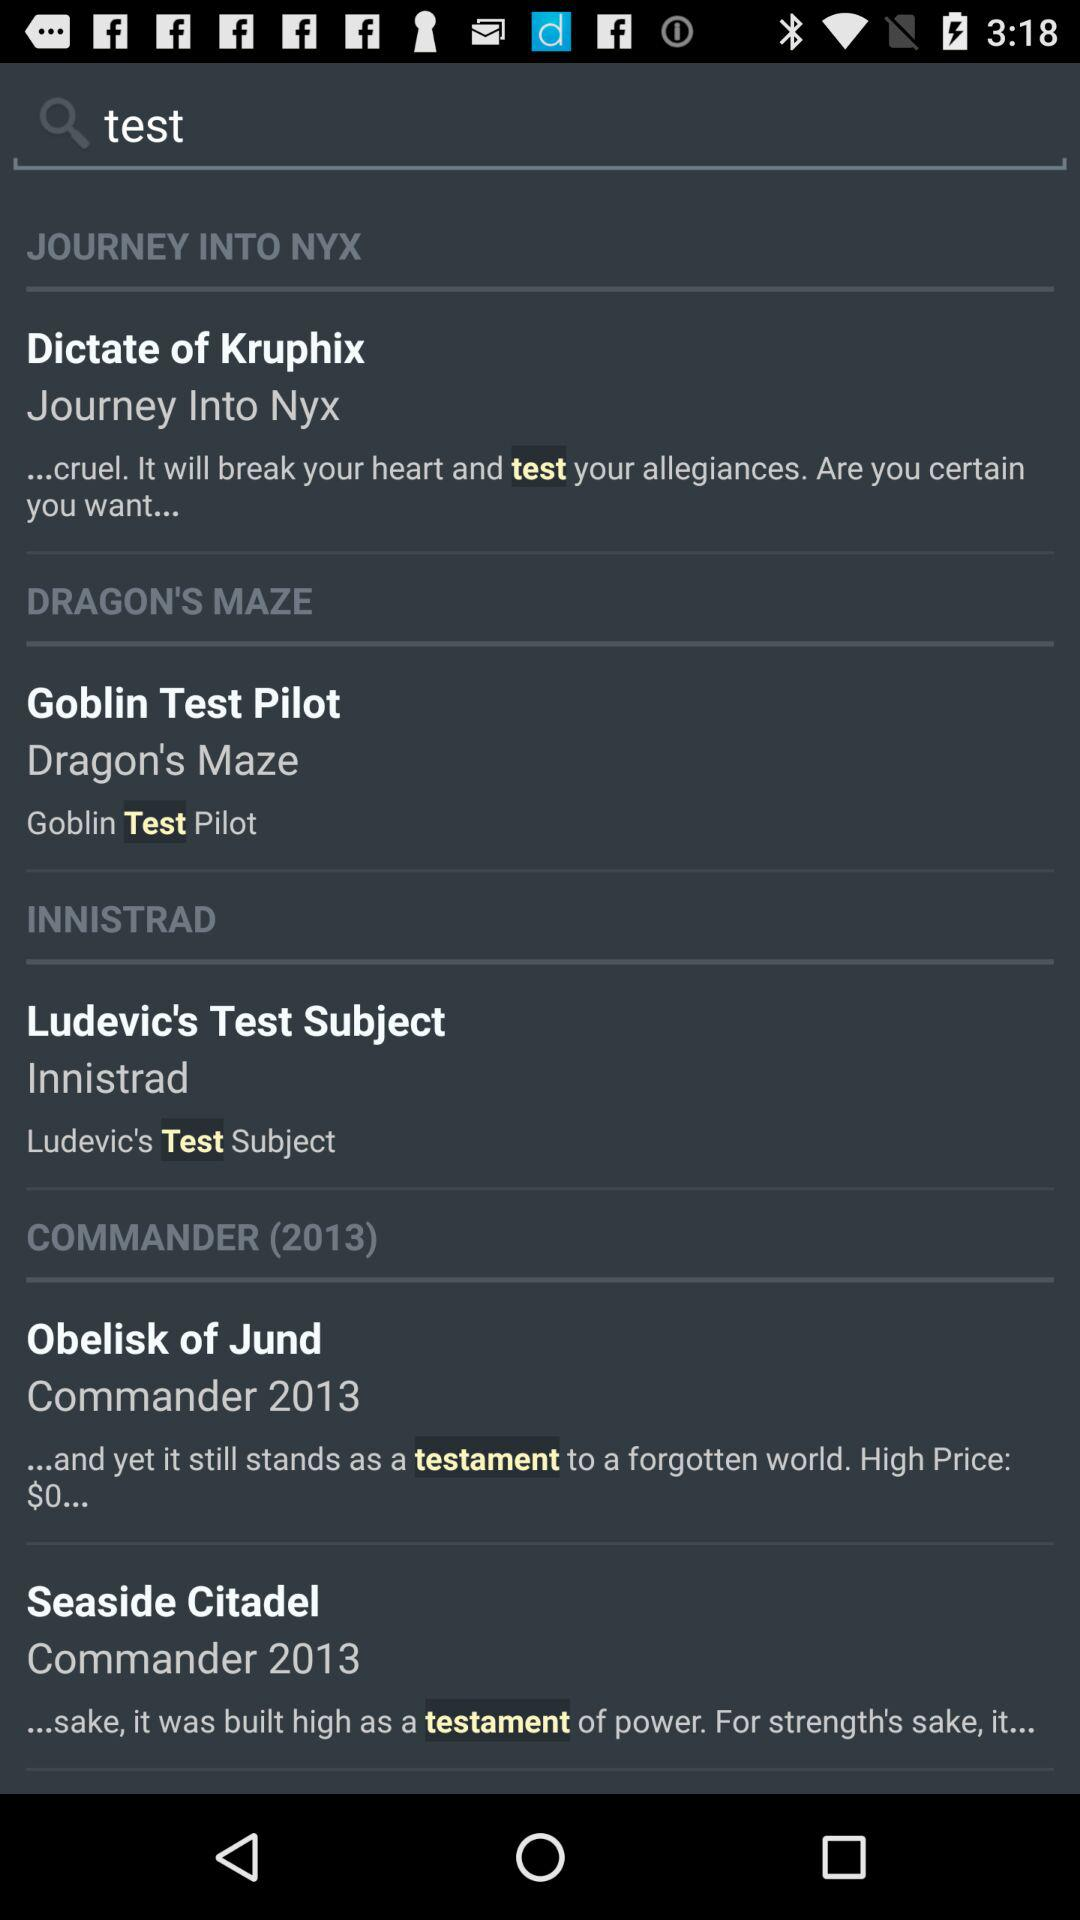How many cards are from the Commander (2013) set?
Answer the question using a single word or phrase. 2 